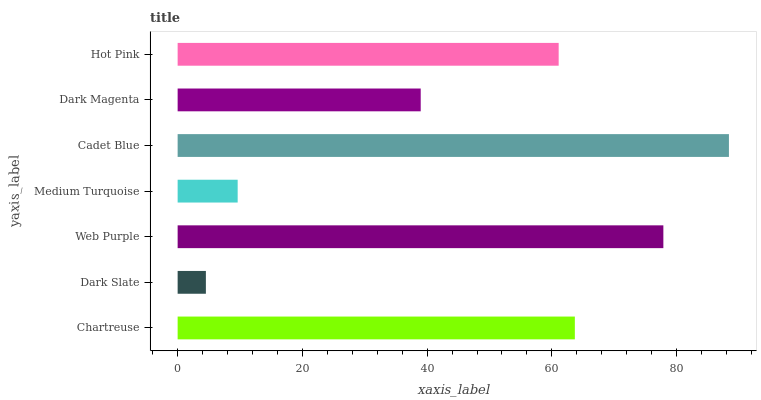Is Dark Slate the minimum?
Answer yes or no. Yes. Is Cadet Blue the maximum?
Answer yes or no. Yes. Is Web Purple the minimum?
Answer yes or no. No. Is Web Purple the maximum?
Answer yes or no. No. Is Web Purple greater than Dark Slate?
Answer yes or no. Yes. Is Dark Slate less than Web Purple?
Answer yes or no. Yes. Is Dark Slate greater than Web Purple?
Answer yes or no. No. Is Web Purple less than Dark Slate?
Answer yes or no. No. Is Hot Pink the high median?
Answer yes or no. Yes. Is Hot Pink the low median?
Answer yes or no. Yes. Is Medium Turquoise the high median?
Answer yes or no. No. Is Chartreuse the low median?
Answer yes or no. No. 